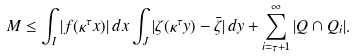<formula> <loc_0><loc_0><loc_500><loc_500>M \leq \int _ { I } | f ( \kappa ^ { \tau } x ) | \, d x \int _ { J } | \zeta ( \kappa ^ { \tau } y ) - \bar { \zeta } | \, d y + \sum _ { i = \tau + 1 } ^ { \infty } | Q \cap Q _ { i } | .</formula> 